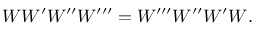<formula> <loc_0><loc_0><loc_500><loc_500>W W ^ { \prime } W ^ { \prime \prime } W ^ { \prime \prime \prime } = W ^ { \prime \prime \prime } W ^ { \prime \prime } W ^ { \prime } W .</formula> 